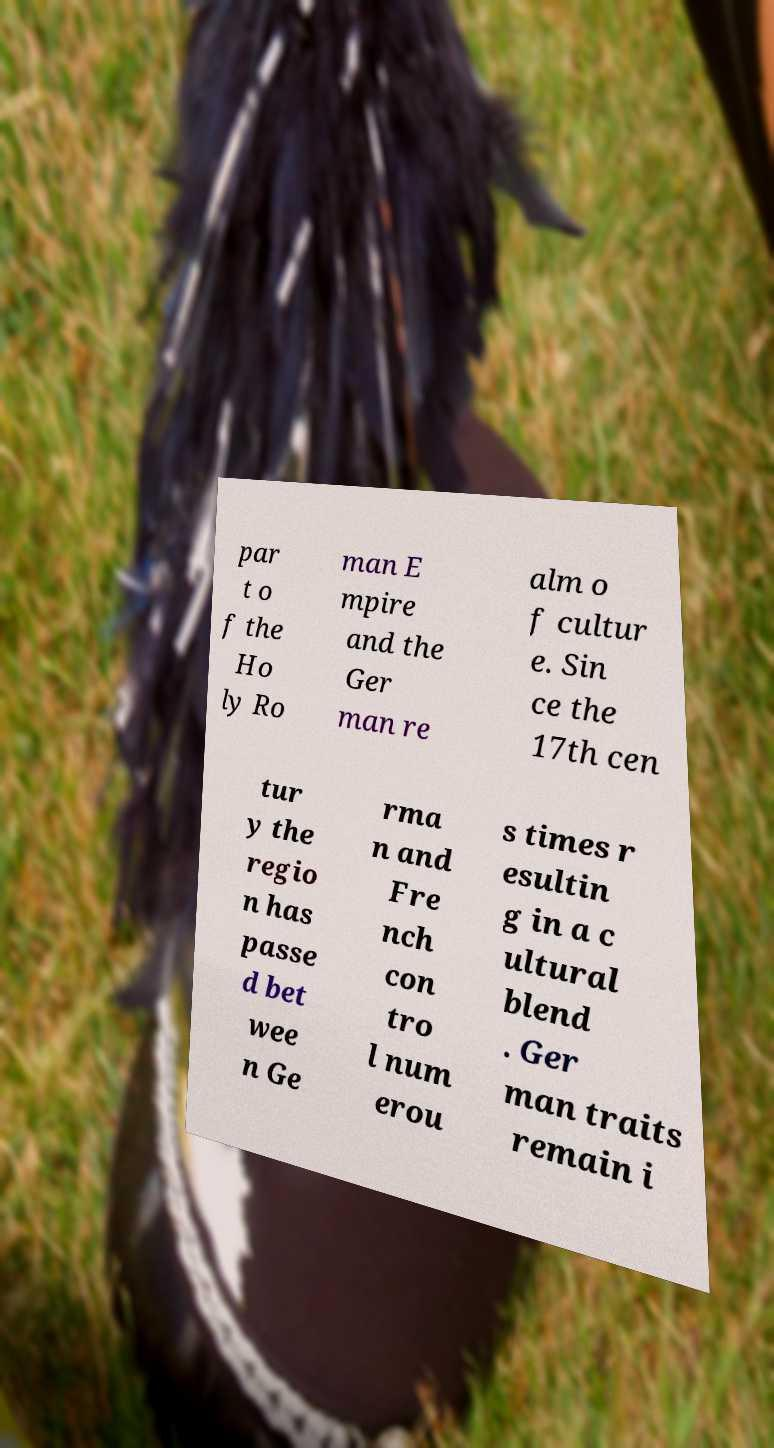Can you accurately transcribe the text from the provided image for me? par t o f the Ho ly Ro man E mpire and the Ger man re alm o f cultur e. Sin ce the 17th cen tur y the regio n has passe d bet wee n Ge rma n and Fre nch con tro l num erou s times r esultin g in a c ultural blend . Ger man traits remain i 